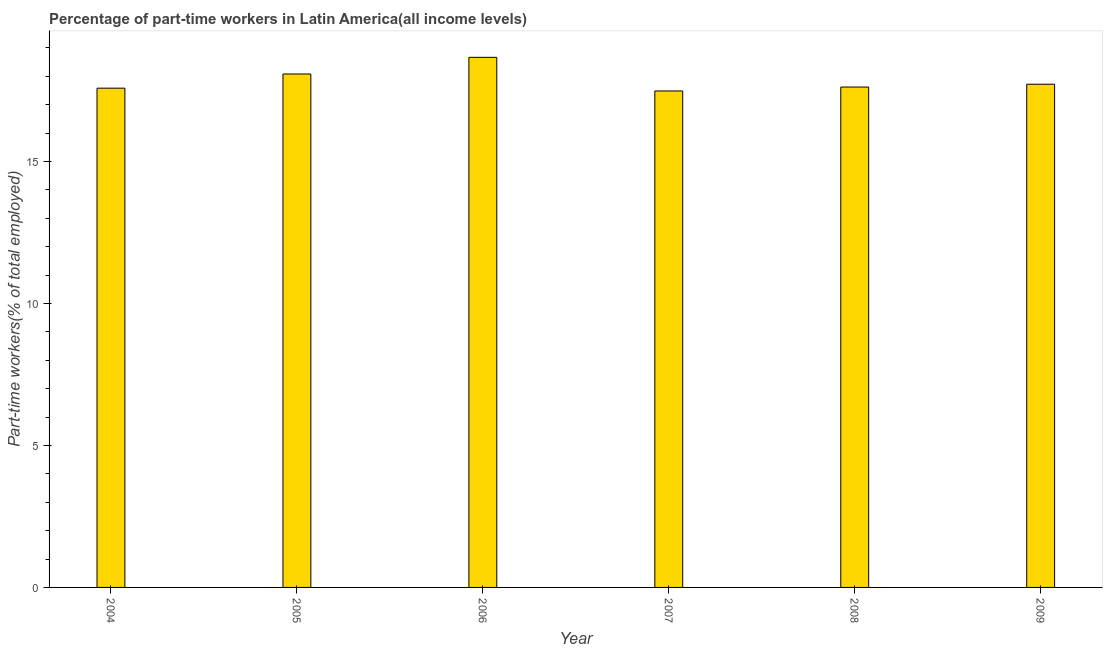Does the graph contain grids?
Give a very brief answer. No. What is the title of the graph?
Your answer should be compact. Percentage of part-time workers in Latin America(all income levels). What is the label or title of the X-axis?
Provide a short and direct response. Year. What is the label or title of the Y-axis?
Ensure brevity in your answer.  Part-time workers(% of total employed). What is the percentage of part-time workers in 2006?
Keep it short and to the point. 18.67. Across all years, what is the maximum percentage of part-time workers?
Offer a very short reply. 18.67. Across all years, what is the minimum percentage of part-time workers?
Offer a terse response. 17.48. In which year was the percentage of part-time workers minimum?
Your answer should be compact. 2007. What is the sum of the percentage of part-time workers?
Your answer should be very brief. 107.15. What is the difference between the percentage of part-time workers in 2004 and 2007?
Keep it short and to the point. 0.1. What is the average percentage of part-time workers per year?
Give a very brief answer. 17.86. What is the median percentage of part-time workers?
Keep it short and to the point. 17.67. Is the difference between the percentage of part-time workers in 2004 and 2009 greater than the difference between any two years?
Your answer should be very brief. No. What is the difference between the highest and the second highest percentage of part-time workers?
Keep it short and to the point. 0.59. Is the sum of the percentage of part-time workers in 2005 and 2009 greater than the maximum percentage of part-time workers across all years?
Provide a short and direct response. Yes. What is the difference between the highest and the lowest percentage of part-time workers?
Your answer should be compact. 1.18. In how many years, is the percentage of part-time workers greater than the average percentage of part-time workers taken over all years?
Your response must be concise. 2. Are all the bars in the graph horizontal?
Provide a succinct answer. No. What is the difference between two consecutive major ticks on the Y-axis?
Keep it short and to the point. 5. What is the Part-time workers(% of total employed) in 2004?
Your answer should be very brief. 17.58. What is the Part-time workers(% of total employed) of 2005?
Provide a succinct answer. 18.08. What is the Part-time workers(% of total employed) in 2006?
Offer a terse response. 18.67. What is the Part-time workers(% of total employed) of 2007?
Provide a short and direct response. 17.48. What is the Part-time workers(% of total employed) in 2008?
Offer a terse response. 17.62. What is the Part-time workers(% of total employed) in 2009?
Provide a succinct answer. 17.72. What is the difference between the Part-time workers(% of total employed) in 2004 and 2005?
Ensure brevity in your answer.  -0.5. What is the difference between the Part-time workers(% of total employed) in 2004 and 2006?
Your answer should be compact. -1.09. What is the difference between the Part-time workers(% of total employed) in 2004 and 2007?
Your answer should be compact. 0.1. What is the difference between the Part-time workers(% of total employed) in 2004 and 2008?
Provide a succinct answer. -0.04. What is the difference between the Part-time workers(% of total employed) in 2004 and 2009?
Your response must be concise. -0.14. What is the difference between the Part-time workers(% of total employed) in 2005 and 2006?
Offer a terse response. -0.59. What is the difference between the Part-time workers(% of total employed) in 2005 and 2007?
Provide a short and direct response. 0.6. What is the difference between the Part-time workers(% of total employed) in 2005 and 2008?
Offer a terse response. 0.46. What is the difference between the Part-time workers(% of total employed) in 2005 and 2009?
Provide a short and direct response. 0.36. What is the difference between the Part-time workers(% of total employed) in 2006 and 2007?
Make the answer very short. 1.18. What is the difference between the Part-time workers(% of total employed) in 2006 and 2008?
Ensure brevity in your answer.  1.05. What is the difference between the Part-time workers(% of total employed) in 2006 and 2009?
Provide a succinct answer. 0.95. What is the difference between the Part-time workers(% of total employed) in 2007 and 2008?
Make the answer very short. -0.14. What is the difference between the Part-time workers(% of total employed) in 2007 and 2009?
Offer a terse response. -0.24. What is the difference between the Part-time workers(% of total employed) in 2008 and 2009?
Make the answer very short. -0.1. What is the ratio of the Part-time workers(% of total employed) in 2004 to that in 2006?
Keep it short and to the point. 0.94. What is the ratio of the Part-time workers(% of total employed) in 2004 to that in 2007?
Ensure brevity in your answer.  1.01. What is the ratio of the Part-time workers(% of total employed) in 2004 to that in 2008?
Provide a short and direct response. 1. What is the ratio of the Part-time workers(% of total employed) in 2004 to that in 2009?
Ensure brevity in your answer.  0.99. What is the ratio of the Part-time workers(% of total employed) in 2005 to that in 2007?
Your response must be concise. 1.03. What is the ratio of the Part-time workers(% of total employed) in 2005 to that in 2008?
Offer a terse response. 1.03. What is the ratio of the Part-time workers(% of total employed) in 2005 to that in 2009?
Make the answer very short. 1.02. What is the ratio of the Part-time workers(% of total employed) in 2006 to that in 2007?
Offer a terse response. 1.07. What is the ratio of the Part-time workers(% of total employed) in 2006 to that in 2008?
Provide a short and direct response. 1.06. What is the ratio of the Part-time workers(% of total employed) in 2006 to that in 2009?
Provide a short and direct response. 1.05. What is the ratio of the Part-time workers(% of total employed) in 2007 to that in 2008?
Provide a succinct answer. 0.99. 